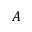<formula> <loc_0><loc_0><loc_500><loc_500>A</formula> 